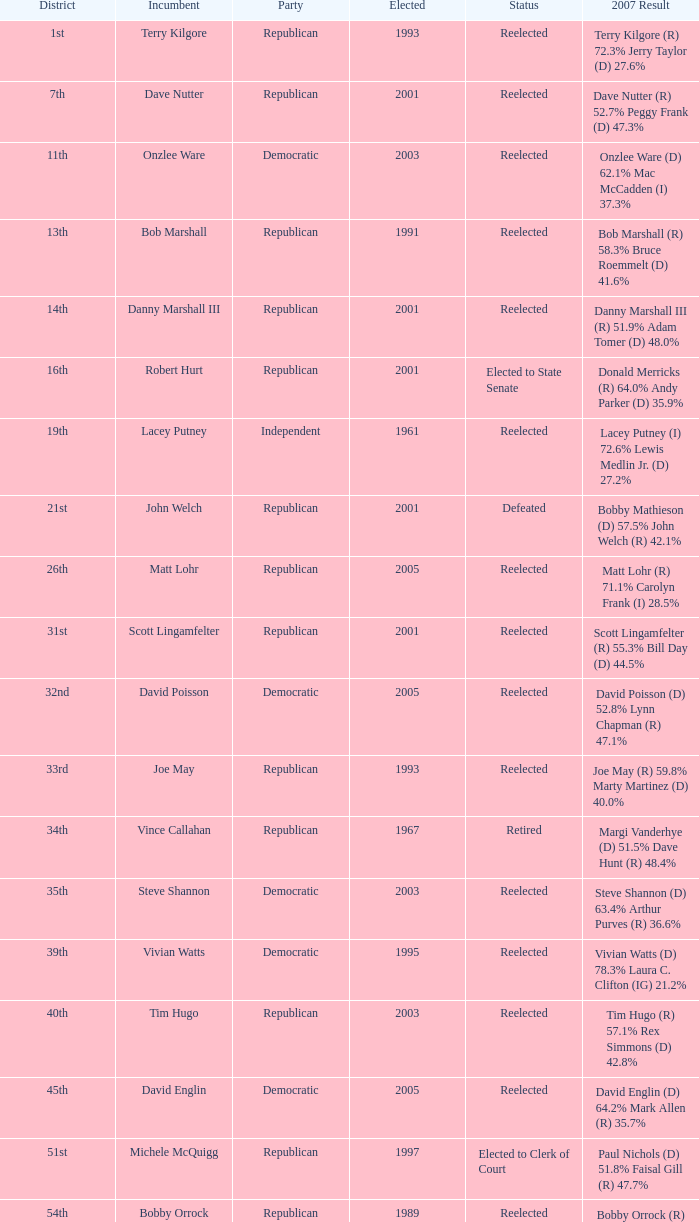Which year marked the most recent election of someone to the 14th district? 2001.0. 